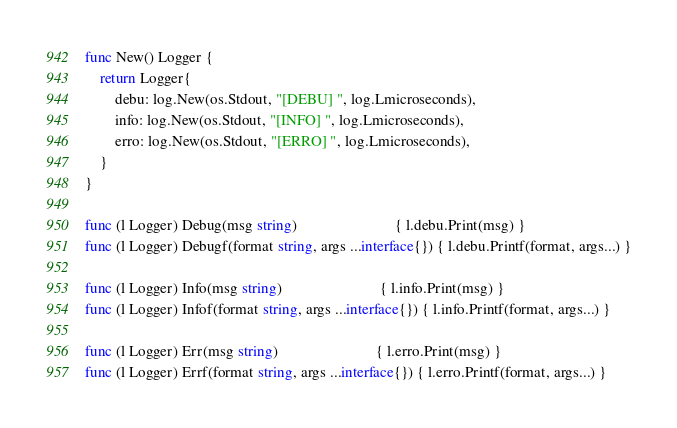<code> <loc_0><loc_0><loc_500><loc_500><_Go_>func New() Logger {
	return Logger{
		debu: log.New(os.Stdout, "[DEBU] ", log.Lmicroseconds),
		info: log.New(os.Stdout, "[INFO] ", log.Lmicroseconds),
		erro: log.New(os.Stdout, "[ERRO] ", log.Lmicroseconds),
	}
}

func (l Logger) Debug(msg string)                          { l.debu.Print(msg) }
func (l Logger) Debugf(format string, args ...interface{}) { l.debu.Printf(format, args...) }

func (l Logger) Info(msg string)                          { l.info.Print(msg) }
func (l Logger) Infof(format string, args ...interface{}) { l.info.Printf(format, args...) }

func (l Logger) Err(msg string)                          { l.erro.Print(msg) }
func (l Logger) Errf(format string, args ...interface{}) { l.erro.Printf(format, args...) }
</code> 